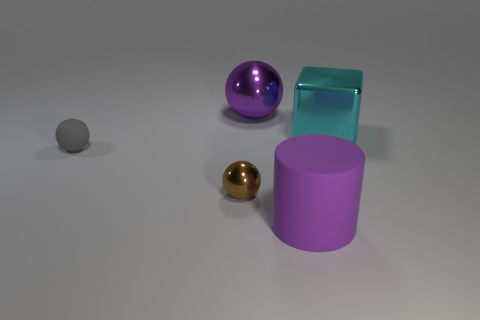How many other objects are the same color as the large matte cylinder? 1 